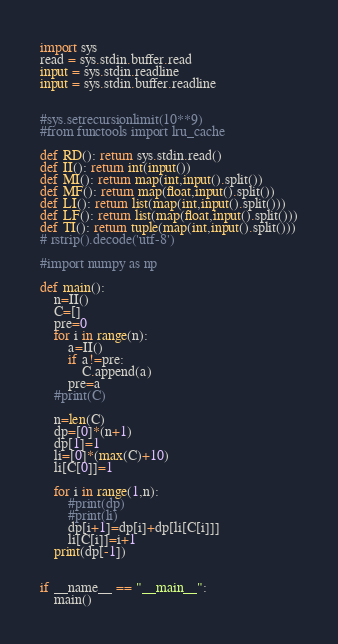Convert code to text. <code><loc_0><loc_0><loc_500><loc_500><_Python_>import sys
read = sys.stdin.buffer.read
input = sys.stdin.readline
input = sys.stdin.buffer.readline


#sys.setrecursionlimit(10**9)
#from functools import lru_cache

def RD(): return sys.stdin.read()
def II(): return int(input())
def MI(): return map(int,input().split())
def MF(): return map(float,input().split())
def LI(): return list(map(int,input().split()))
def LF(): return list(map(float,input().split()))
def TI(): return tuple(map(int,input().split()))
# rstrip().decode('utf-8')

#import numpy as np

def main():
	n=II()
	C=[]
	pre=0
	for i in range(n):
		a=II()
		if a!=pre:
			C.append(a)
		pre=a
	#print(C)

	n=len(C)
	dp=[0]*(n+1)
	dp[1]=1
	li=[0]*(max(C)+10)
	li[C[0]]=1

	for i in range(1,n):
		#print(dp)
		#print(li)
		dp[i+1]=dp[i]+dp[li[C[i]]]
		li[C[i]]=i+1
	print(dp[-1])


if __name__ == "__main__":
	main()</code> 